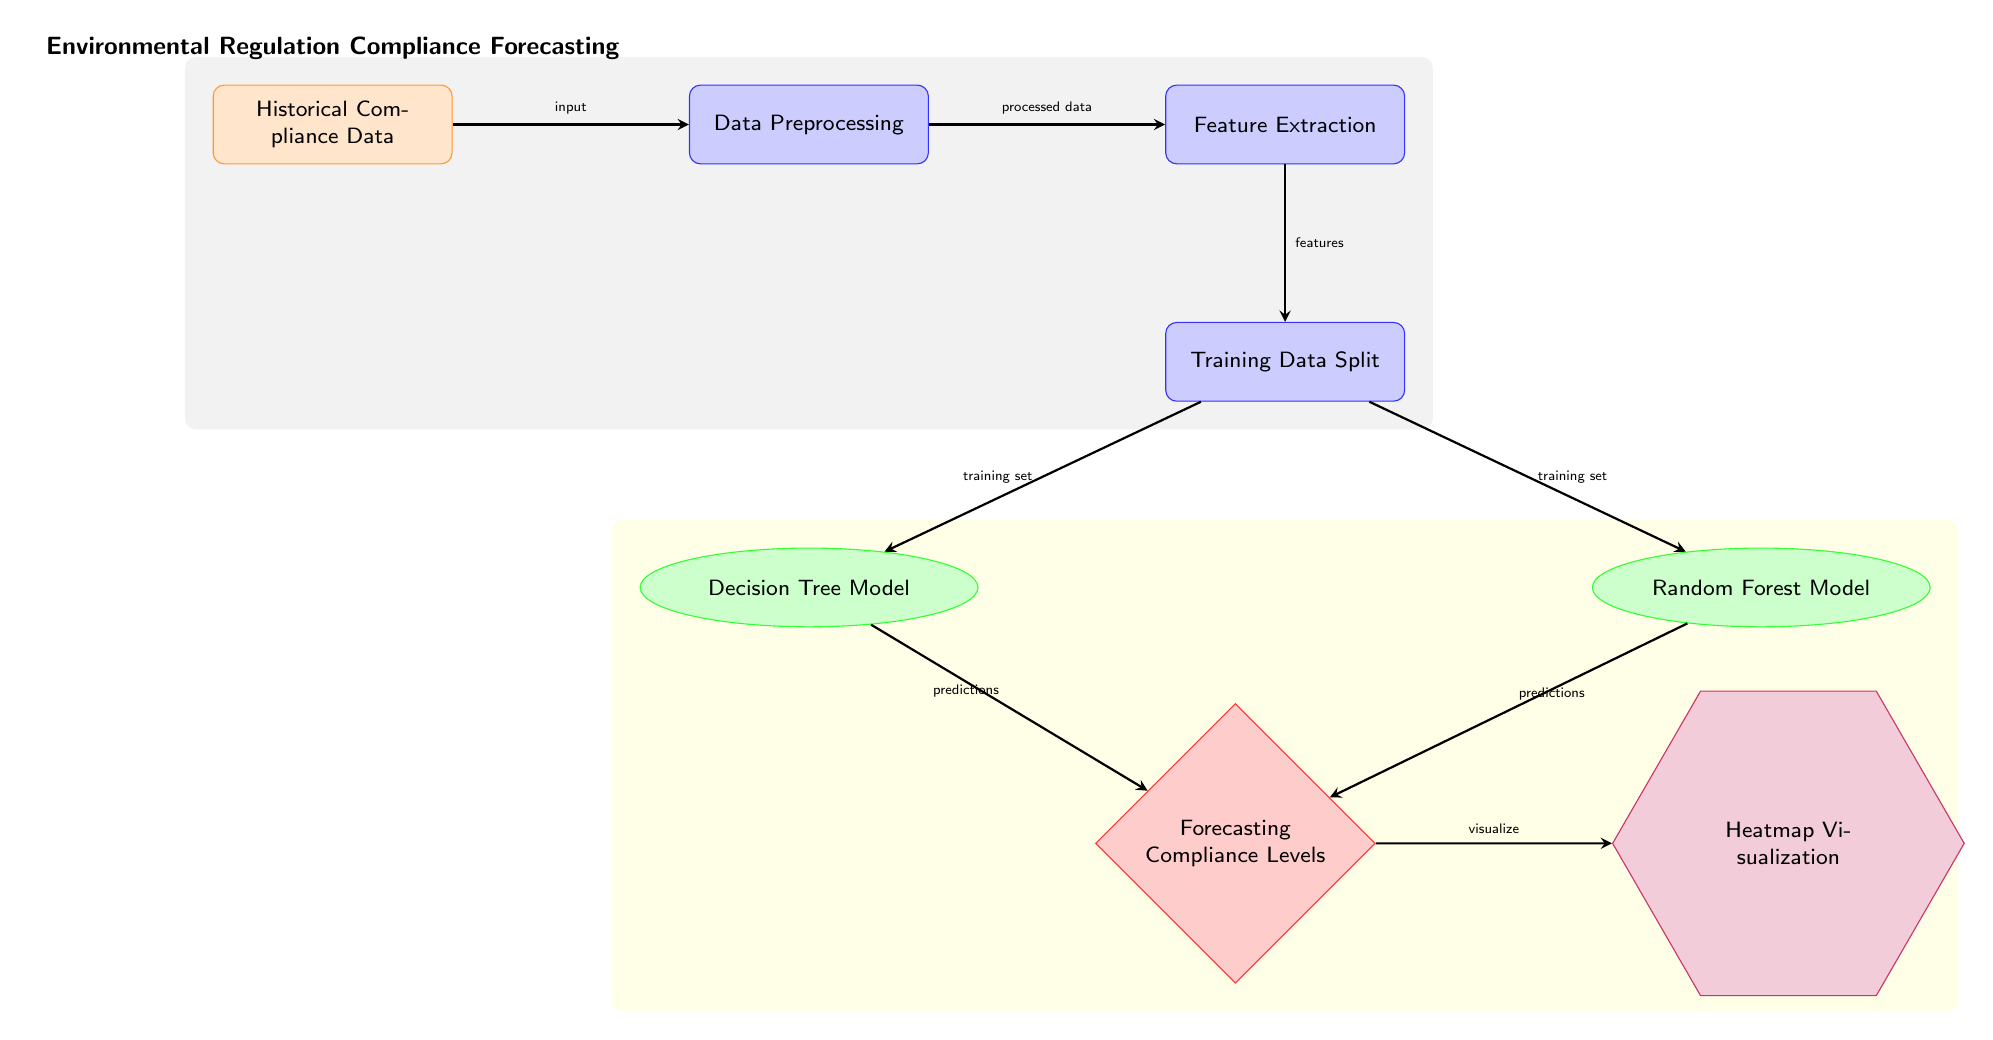What is the first node in the diagram? The first node is historical compliance data, which signifies the starting point of the process where the relevant data is collected.
Answer: Historical Compliance Data How many machine learning models are present in the diagram? The diagram displays two machine learning models, specifically the decision tree model and the random forest model, as indicated in the algorithm nodes.
Answer: 2 What type of visualization is generated at the end of the process? At the end of the process, a heatmap visualization is generated, which helps to visually represent the forecasting results.
Answer: Heatmap Visualization What connects the data preprocessing and feature extraction nodes? The connection between the data preprocessing and feature extraction nodes is indicated by the arrow labeled 'processed data', showing the flow of information from preprocessing to feature extraction.
Answer: Processed Data Which node has the output type shape? The output node is shaped like a diamond and is labeled "Forecasting Compliance Levels", indicating it is a critical output of the forecasting process.
Answer: Forecasting Compliance Levels What is the output of the decision tree model node? The output of the decision tree model is labeled as 'predictions', which means it contributes predictions to the forecasting compliance levels.
Answer: Predictions What happens to the training data split? The training data split leads to two separate paths, one going to the decision tree model and the other to the random forest model, signifying the division of data for training these models.
Answer: Divides into two paths What is the purpose of the feature extraction node? The feature extraction node serves the purpose of extracting relevant features from the processed data, which is essential for creating effective machine learning models.
Answer: Extracting Features What is the color of the process nodes in the diagram? The process nodes, such as data preprocessing and feature extraction, are depicted in blue, signifying their role in the overall process flow.
Answer: Blue 